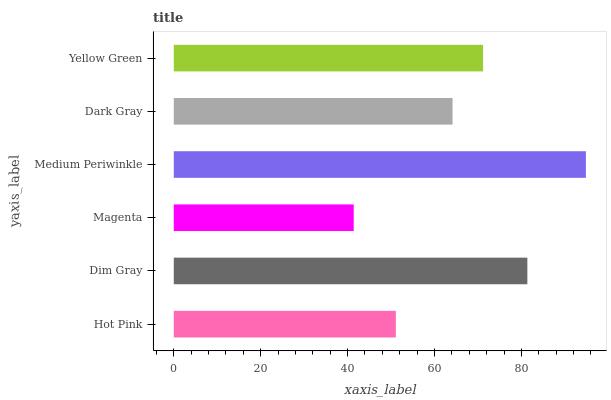Is Magenta the minimum?
Answer yes or no. Yes. Is Medium Periwinkle the maximum?
Answer yes or no. Yes. Is Dim Gray the minimum?
Answer yes or no. No. Is Dim Gray the maximum?
Answer yes or no. No. Is Dim Gray greater than Hot Pink?
Answer yes or no. Yes. Is Hot Pink less than Dim Gray?
Answer yes or no. Yes. Is Hot Pink greater than Dim Gray?
Answer yes or no. No. Is Dim Gray less than Hot Pink?
Answer yes or no. No. Is Yellow Green the high median?
Answer yes or no. Yes. Is Dark Gray the low median?
Answer yes or no. Yes. Is Hot Pink the high median?
Answer yes or no. No. Is Magenta the low median?
Answer yes or no. No. 